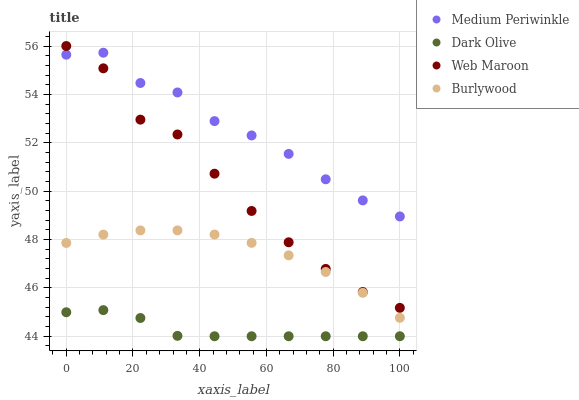Does Dark Olive have the minimum area under the curve?
Answer yes or no. Yes. Does Medium Periwinkle have the maximum area under the curve?
Answer yes or no. Yes. Does Web Maroon have the minimum area under the curve?
Answer yes or no. No. Does Web Maroon have the maximum area under the curve?
Answer yes or no. No. Is Burlywood the smoothest?
Answer yes or no. Yes. Is Web Maroon the roughest?
Answer yes or no. Yes. Is Dark Olive the smoothest?
Answer yes or no. No. Is Dark Olive the roughest?
Answer yes or no. No. Does Dark Olive have the lowest value?
Answer yes or no. Yes. Does Web Maroon have the lowest value?
Answer yes or no. No. Does Web Maroon have the highest value?
Answer yes or no. Yes. Does Dark Olive have the highest value?
Answer yes or no. No. Is Dark Olive less than Web Maroon?
Answer yes or no. Yes. Is Medium Periwinkle greater than Dark Olive?
Answer yes or no. Yes. Does Medium Periwinkle intersect Web Maroon?
Answer yes or no. Yes. Is Medium Periwinkle less than Web Maroon?
Answer yes or no. No. Is Medium Periwinkle greater than Web Maroon?
Answer yes or no. No. Does Dark Olive intersect Web Maroon?
Answer yes or no. No. 